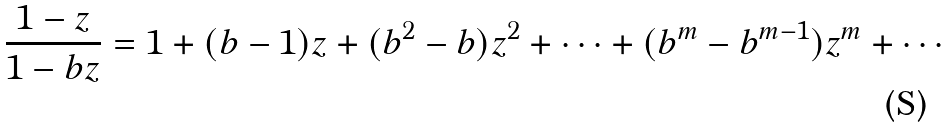Convert formula to latex. <formula><loc_0><loc_0><loc_500><loc_500>\frac { 1 - z } { 1 - b z } = 1 + ( b - 1 ) z + ( b ^ { 2 } - b ) z ^ { 2 } + \cdots + ( b ^ { m } - b ^ { m - 1 } ) z ^ { m } + \cdots</formula> 